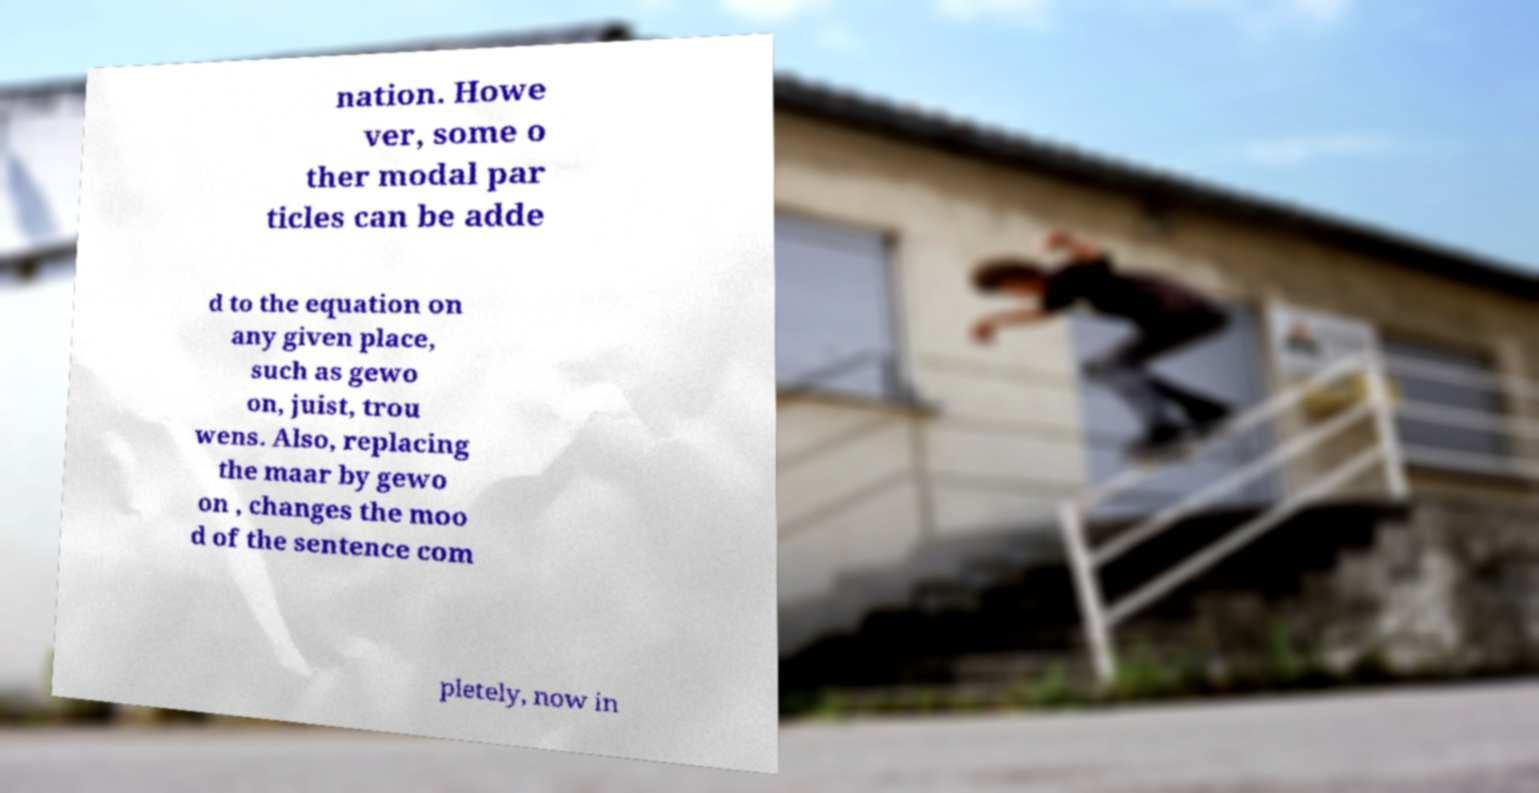Could you assist in decoding the text presented in this image and type it out clearly? nation. Howe ver, some o ther modal par ticles can be adde d to the equation on any given place, such as gewo on, juist, trou wens. Also, replacing the maar by gewo on , changes the moo d of the sentence com pletely, now in 